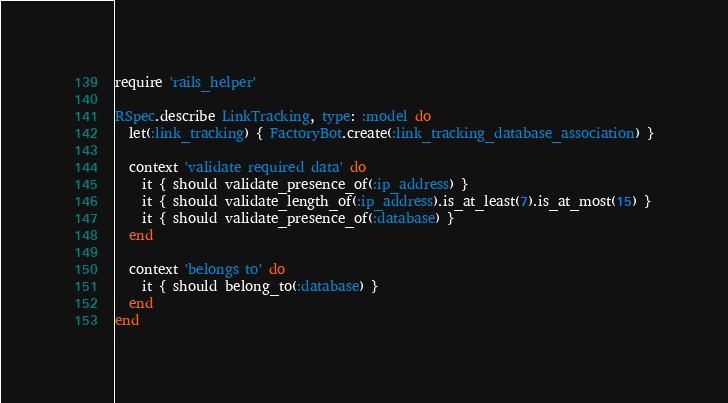Convert code to text. <code><loc_0><loc_0><loc_500><loc_500><_Ruby_>require 'rails_helper'

RSpec.describe LinkTracking, type: :model do
  let(:link_tracking) { FactoryBot.create(:link_tracking_database_association) }
 
  context 'validate required data' do
    it { should validate_presence_of(:ip_address) }
    it { should validate_length_of(:ip_address).is_at_least(7).is_at_most(15) }
    it { should validate_presence_of(:database) }
  end  

  context 'belongs to' do
    it { should belong_to(:database) }
  end  
end
</code> 